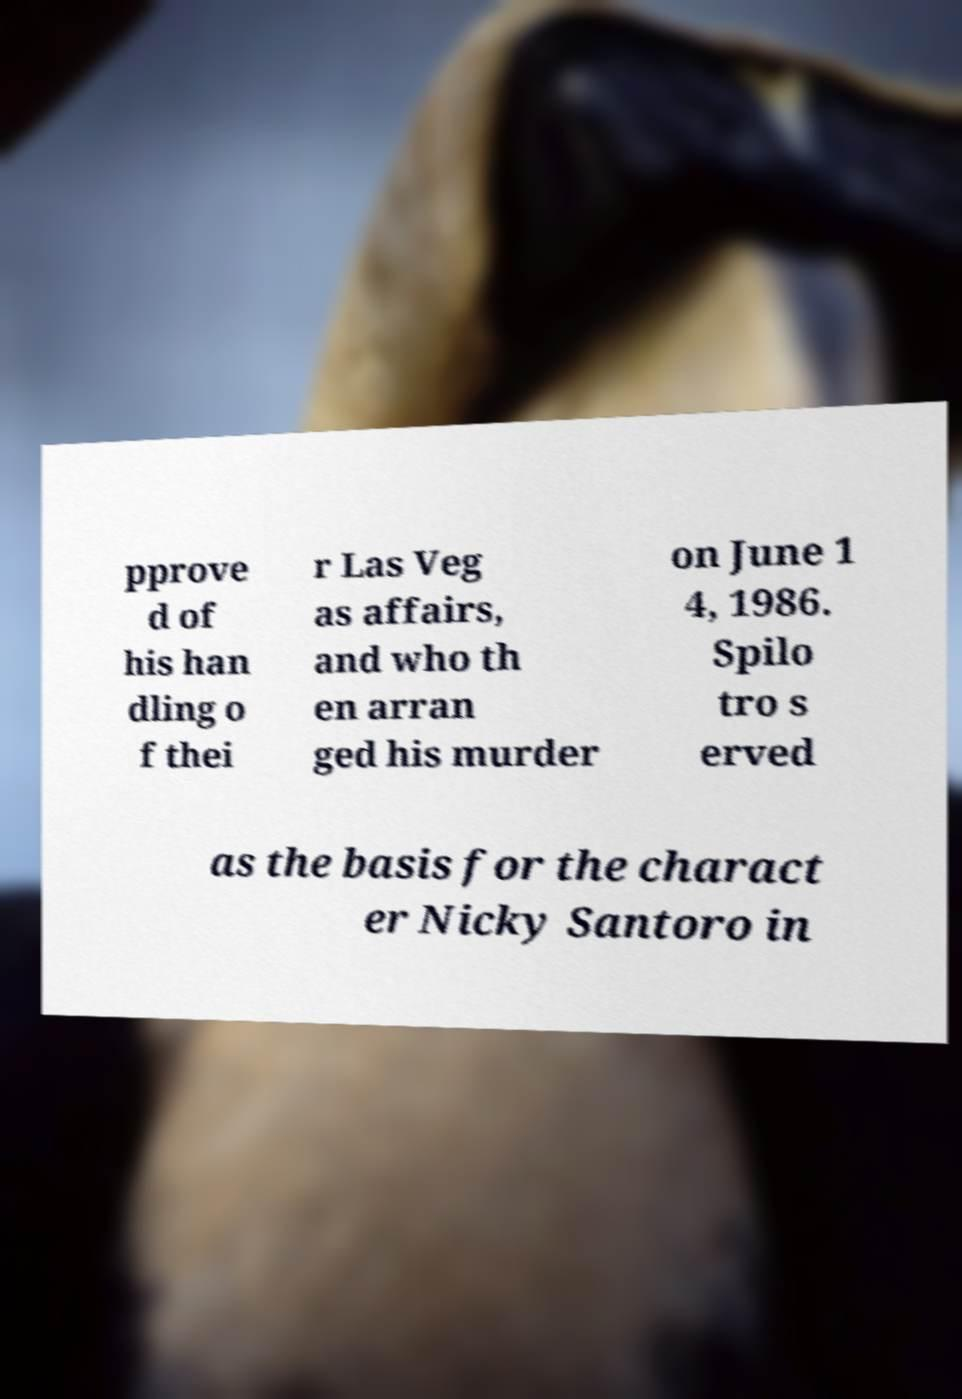Can you accurately transcribe the text from the provided image for me? pprove d of his han dling o f thei r Las Veg as affairs, and who th en arran ged his murder on June 1 4, 1986. Spilo tro s erved as the basis for the charact er Nicky Santoro in 